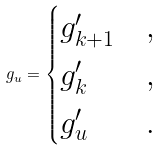<formula> <loc_0><loc_0><loc_500><loc_500>g _ { u } = \begin{cases} g ^ { \prime } _ { k + 1 } & , \\ g ^ { \prime } _ { k } & , \\ g ^ { \prime } _ { u } & . \end{cases}</formula> 